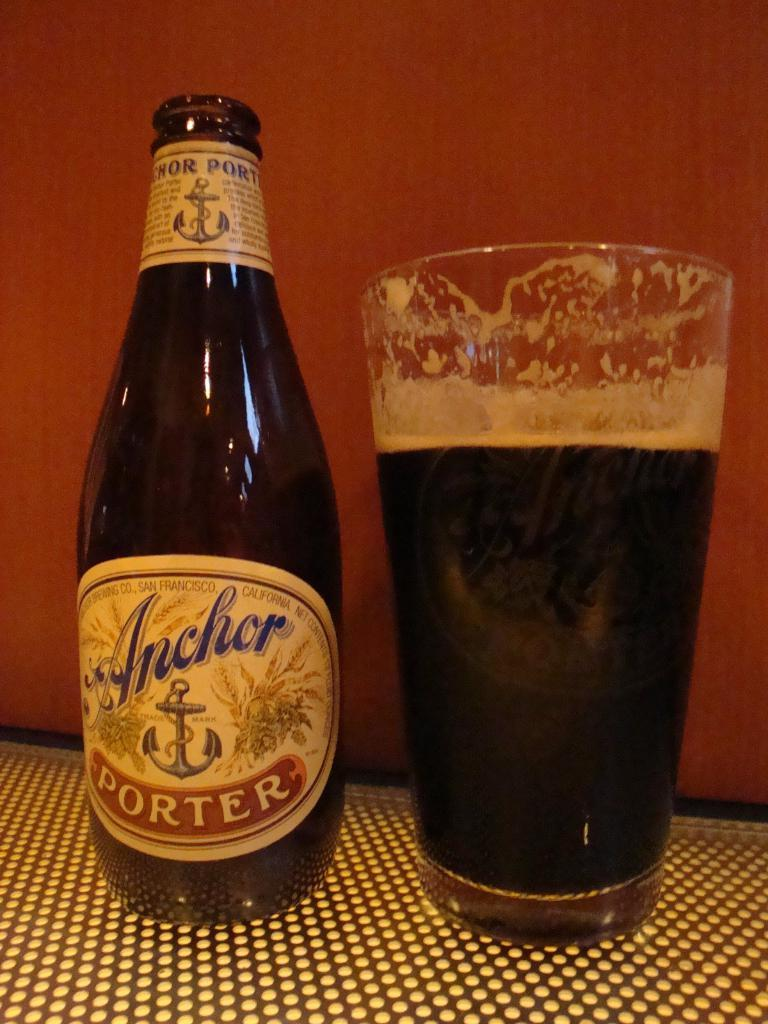<image>
Provide a brief description of the given image. A bottle of Anchor Porter ale is next to a drinking glass full of beer 